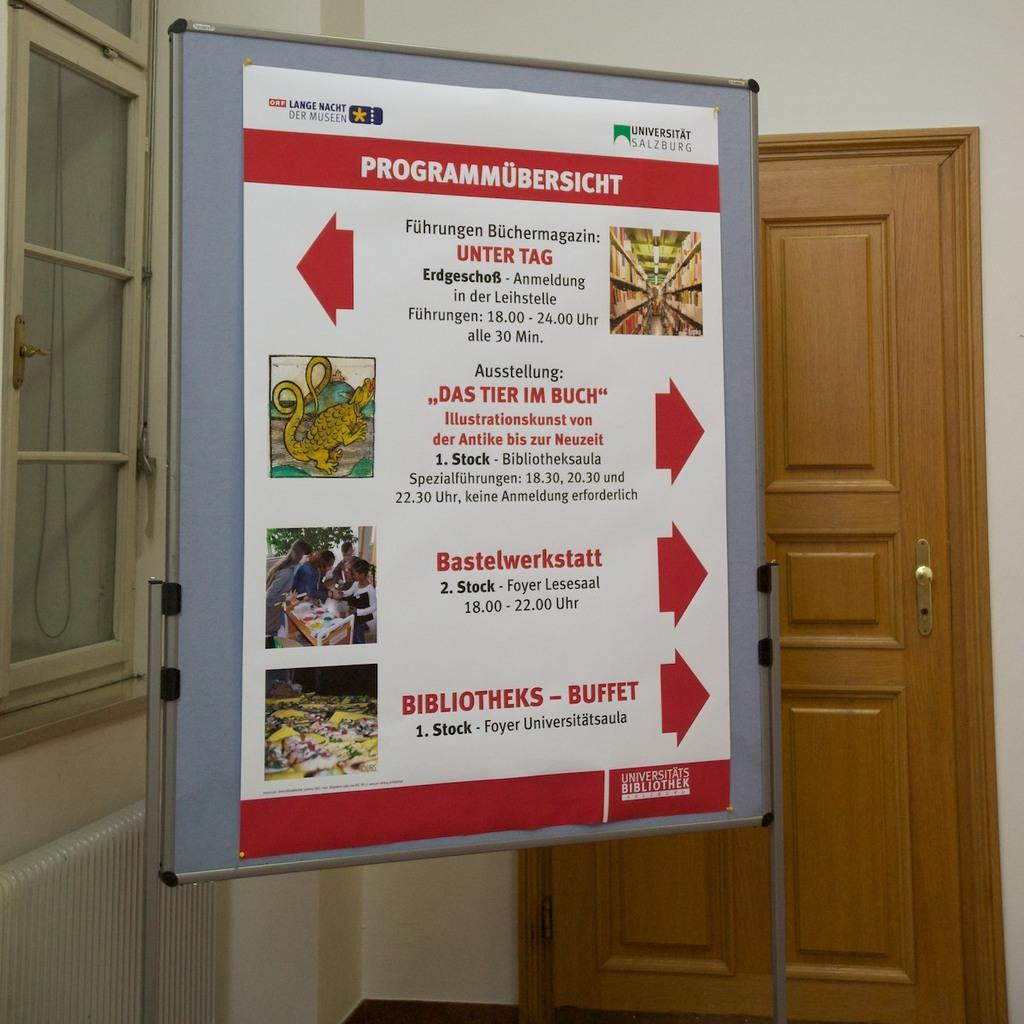<image>
Give a short and clear explanation of the subsequent image. Sign that points directions for  Universitats Bibliothek 